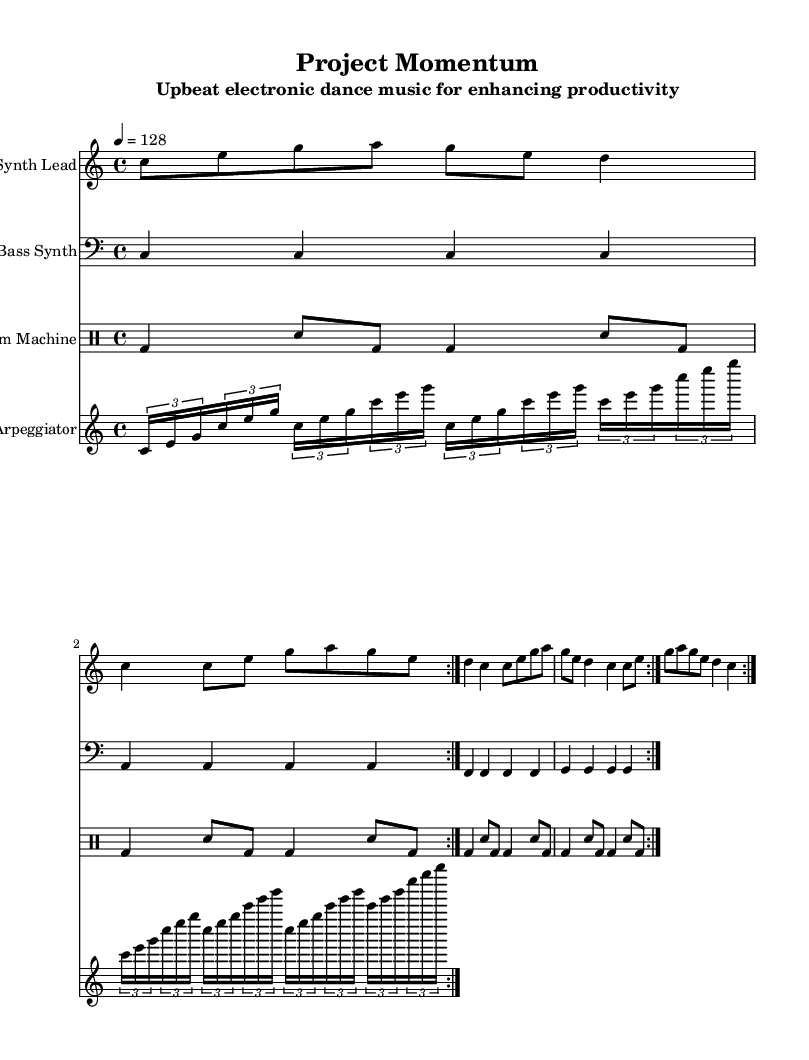What is the key signature of this music? The key signature is indicated at the beginning of the staff, showing no sharps or flats, which corresponds to the C major scale.
Answer: C major What is the time signature of this music? The time signature is found at the beginning of the score, showing a top number of 4 and a bottom number of 4, indicating four beats per measure with a quarter note receiving one beat.
Answer: 4/4 What is the tempo marking provided? The tempo marking is indicated by a number in beats per minute (BPM), specifically "4 = 128," which communicates that there are 128 beats in one minute at a quarter note speed.
Answer: 128 How many measures are in the synth lead part? The synth lead part consists of four measures, repeated twice, which can be counted in the score where the measures are clearly marked by vertical lines.
Answer: 8 What type of instrument is the bass synth categorized as? The bass synth is noted to be in a lower range, which is identified as a bass clef, typically used for lower-pitched sounds in music.
Answer: Bass Synth What rhythmic pattern does the drum machine utilize? The drum machine showcases a consistent pattern of bass drum and snare hits, repeated throughout the piece, revealing the dance-oriented rhythmic drive essential for electronic music.
Answer: Alternating bass and snare What is the purpose of the arpeggiator in this composition? The arpeggiator in this sheet music is used to create a cascading effect of chords broken into individual notes, enhancing the upbeat electronic texture commonly found in dance music.
Answer: Texture enhancement 